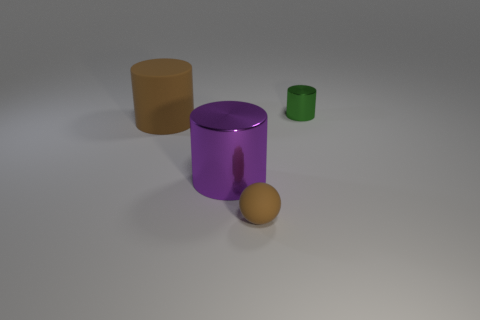Are there any shadows indicating the light source position? Yes, there are shadows extending to the right of each object, suggesting the light source is positioned to the left of the scene.  How does the shadow intensity vary between objects? The intensity of the shadows varies slightly, which could be a combination of the object's height, its distance from the light source, and its material properties that affect how it absorbs and reflects light. 